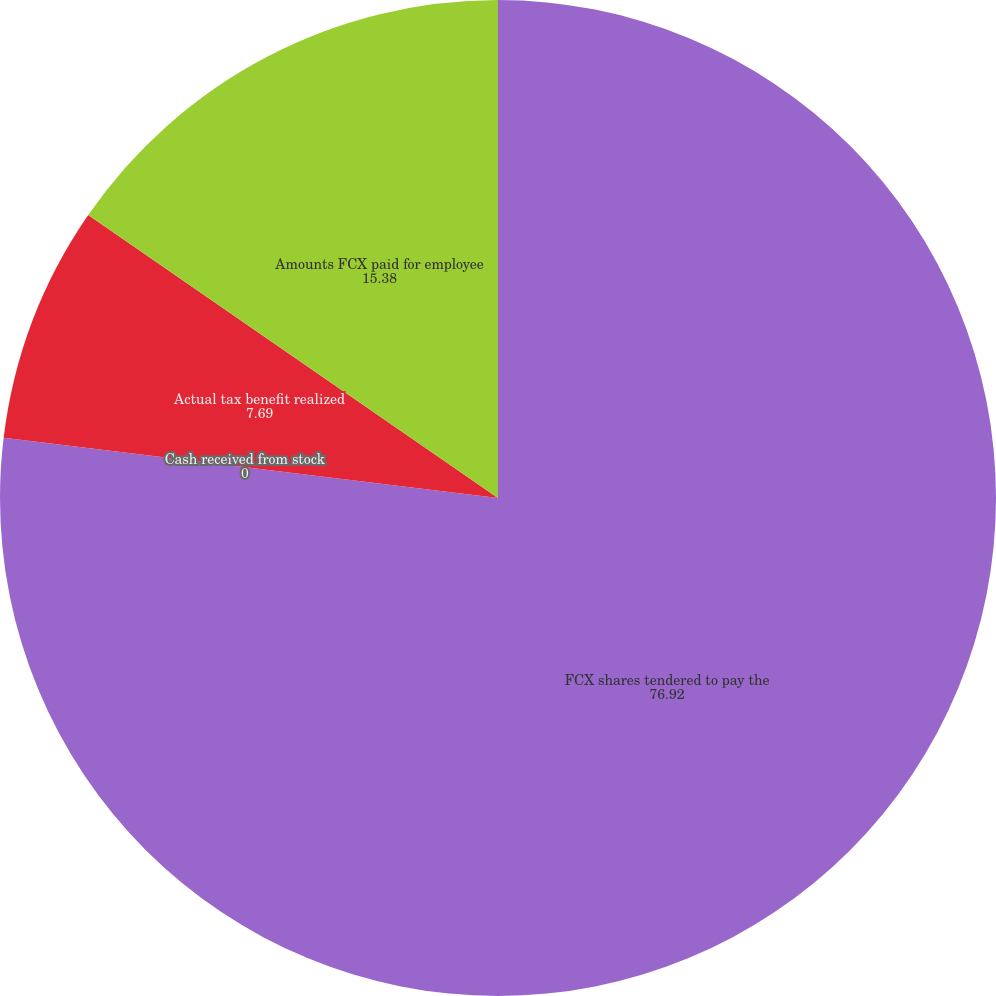Convert chart to OTSL. <chart><loc_0><loc_0><loc_500><loc_500><pie_chart><fcel>FCX shares tendered to pay the<fcel>Cash received from stock<fcel>Actual tax benefit realized<fcel>Amounts FCX paid for employee<nl><fcel>76.92%<fcel>0.0%<fcel>7.69%<fcel>15.38%<nl></chart> 